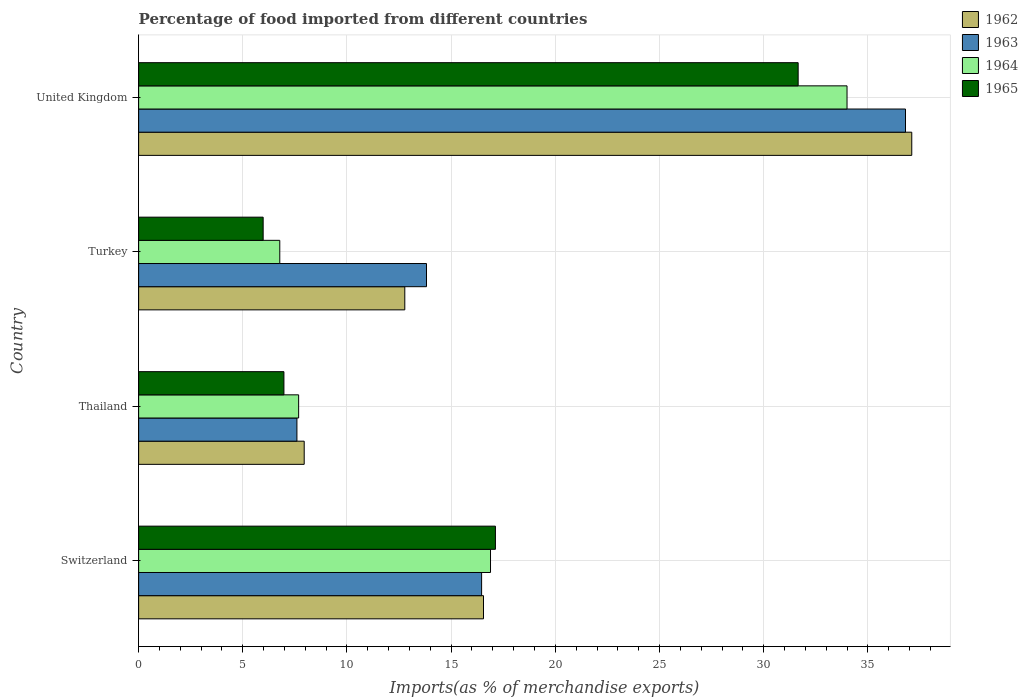How many different coloured bars are there?
Your answer should be compact. 4. How many groups of bars are there?
Offer a terse response. 4. Are the number of bars per tick equal to the number of legend labels?
Keep it short and to the point. Yes. Are the number of bars on each tick of the Y-axis equal?
Provide a short and direct response. Yes. What is the label of the 3rd group of bars from the top?
Ensure brevity in your answer.  Thailand. In how many cases, is the number of bars for a given country not equal to the number of legend labels?
Provide a short and direct response. 0. What is the percentage of imports to different countries in 1963 in Switzerland?
Your answer should be compact. 16.46. Across all countries, what is the maximum percentage of imports to different countries in 1962?
Keep it short and to the point. 37.11. Across all countries, what is the minimum percentage of imports to different countries in 1964?
Offer a terse response. 6.77. In which country was the percentage of imports to different countries in 1963 maximum?
Provide a short and direct response. United Kingdom. In which country was the percentage of imports to different countries in 1964 minimum?
Offer a very short reply. Turkey. What is the total percentage of imports to different countries in 1963 in the graph?
Offer a terse response. 74.68. What is the difference between the percentage of imports to different countries in 1963 in Thailand and that in Turkey?
Ensure brevity in your answer.  -6.22. What is the difference between the percentage of imports to different countries in 1965 in Turkey and the percentage of imports to different countries in 1962 in Thailand?
Your answer should be very brief. -1.97. What is the average percentage of imports to different countries in 1965 per country?
Your answer should be compact. 15.43. What is the difference between the percentage of imports to different countries in 1962 and percentage of imports to different countries in 1965 in Thailand?
Ensure brevity in your answer.  0.97. What is the ratio of the percentage of imports to different countries in 1964 in Switzerland to that in Turkey?
Your answer should be compact. 2.49. Is the percentage of imports to different countries in 1965 in Switzerland less than that in Thailand?
Your response must be concise. No. What is the difference between the highest and the second highest percentage of imports to different countries in 1962?
Your response must be concise. 20.56. What is the difference between the highest and the lowest percentage of imports to different countries in 1962?
Your answer should be very brief. 29.16. Is it the case that in every country, the sum of the percentage of imports to different countries in 1965 and percentage of imports to different countries in 1964 is greater than the sum of percentage of imports to different countries in 1962 and percentage of imports to different countries in 1963?
Your answer should be compact. No. What does the 4th bar from the bottom in United Kingdom represents?
Provide a short and direct response. 1965. Is it the case that in every country, the sum of the percentage of imports to different countries in 1963 and percentage of imports to different countries in 1965 is greater than the percentage of imports to different countries in 1964?
Give a very brief answer. Yes. Are all the bars in the graph horizontal?
Keep it short and to the point. Yes. What is the difference between two consecutive major ticks on the X-axis?
Offer a terse response. 5. Where does the legend appear in the graph?
Offer a very short reply. Top right. How many legend labels are there?
Offer a very short reply. 4. How are the legend labels stacked?
Your answer should be very brief. Vertical. What is the title of the graph?
Ensure brevity in your answer.  Percentage of food imported from different countries. Does "1976" appear as one of the legend labels in the graph?
Ensure brevity in your answer.  No. What is the label or title of the X-axis?
Your answer should be compact. Imports(as % of merchandise exports). What is the label or title of the Y-axis?
Your response must be concise. Country. What is the Imports(as % of merchandise exports) in 1962 in Switzerland?
Provide a succinct answer. 16.55. What is the Imports(as % of merchandise exports) in 1963 in Switzerland?
Offer a very short reply. 16.46. What is the Imports(as % of merchandise exports) in 1964 in Switzerland?
Offer a very short reply. 16.89. What is the Imports(as % of merchandise exports) in 1965 in Switzerland?
Give a very brief answer. 17.12. What is the Imports(as % of merchandise exports) of 1962 in Thailand?
Keep it short and to the point. 7.95. What is the Imports(as % of merchandise exports) of 1963 in Thailand?
Offer a terse response. 7.6. What is the Imports(as % of merchandise exports) of 1964 in Thailand?
Your answer should be compact. 7.68. What is the Imports(as % of merchandise exports) in 1965 in Thailand?
Your response must be concise. 6.97. What is the Imports(as % of merchandise exports) in 1962 in Turkey?
Provide a succinct answer. 12.77. What is the Imports(as % of merchandise exports) of 1963 in Turkey?
Ensure brevity in your answer.  13.82. What is the Imports(as % of merchandise exports) in 1964 in Turkey?
Offer a terse response. 6.77. What is the Imports(as % of merchandise exports) in 1965 in Turkey?
Give a very brief answer. 5.98. What is the Imports(as % of merchandise exports) in 1962 in United Kingdom?
Offer a very short reply. 37.11. What is the Imports(as % of merchandise exports) of 1963 in United Kingdom?
Your answer should be compact. 36.81. What is the Imports(as % of merchandise exports) of 1964 in United Kingdom?
Your answer should be very brief. 34. What is the Imports(as % of merchandise exports) of 1965 in United Kingdom?
Keep it short and to the point. 31.65. Across all countries, what is the maximum Imports(as % of merchandise exports) of 1962?
Ensure brevity in your answer.  37.11. Across all countries, what is the maximum Imports(as % of merchandise exports) in 1963?
Offer a very short reply. 36.81. Across all countries, what is the maximum Imports(as % of merchandise exports) of 1964?
Give a very brief answer. 34. Across all countries, what is the maximum Imports(as % of merchandise exports) of 1965?
Make the answer very short. 31.65. Across all countries, what is the minimum Imports(as % of merchandise exports) of 1962?
Keep it short and to the point. 7.95. Across all countries, what is the minimum Imports(as % of merchandise exports) of 1963?
Provide a succinct answer. 7.6. Across all countries, what is the minimum Imports(as % of merchandise exports) in 1964?
Ensure brevity in your answer.  6.77. Across all countries, what is the minimum Imports(as % of merchandise exports) in 1965?
Your answer should be compact. 5.98. What is the total Imports(as % of merchandise exports) of 1962 in the graph?
Keep it short and to the point. 74.38. What is the total Imports(as % of merchandise exports) of 1963 in the graph?
Your answer should be very brief. 74.68. What is the total Imports(as % of merchandise exports) in 1964 in the graph?
Your answer should be very brief. 65.34. What is the total Imports(as % of merchandise exports) in 1965 in the graph?
Your answer should be very brief. 61.73. What is the difference between the Imports(as % of merchandise exports) in 1962 in Switzerland and that in Thailand?
Provide a short and direct response. 8.61. What is the difference between the Imports(as % of merchandise exports) of 1963 in Switzerland and that in Thailand?
Your answer should be very brief. 8.86. What is the difference between the Imports(as % of merchandise exports) of 1964 in Switzerland and that in Thailand?
Make the answer very short. 9.21. What is the difference between the Imports(as % of merchandise exports) of 1965 in Switzerland and that in Thailand?
Offer a very short reply. 10.15. What is the difference between the Imports(as % of merchandise exports) in 1962 in Switzerland and that in Turkey?
Ensure brevity in your answer.  3.78. What is the difference between the Imports(as % of merchandise exports) of 1963 in Switzerland and that in Turkey?
Offer a terse response. 2.64. What is the difference between the Imports(as % of merchandise exports) in 1964 in Switzerland and that in Turkey?
Keep it short and to the point. 10.11. What is the difference between the Imports(as % of merchandise exports) in 1965 in Switzerland and that in Turkey?
Your answer should be compact. 11.15. What is the difference between the Imports(as % of merchandise exports) in 1962 in Switzerland and that in United Kingdom?
Ensure brevity in your answer.  -20.56. What is the difference between the Imports(as % of merchandise exports) of 1963 in Switzerland and that in United Kingdom?
Your answer should be compact. -20.35. What is the difference between the Imports(as % of merchandise exports) in 1964 in Switzerland and that in United Kingdom?
Your answer should be compact. -17.11. What is the difference between the Imports(as % of merchandise exports) of 1965 in Switzerland and that in United Kingdom?
Ensure brevity in your answer.  -14.53. What is the difference between the Imports(as % of merchandise exports) in 1962 in Thailand and that in Turkey?
Provide a succinct answer. -4.83. What is the difference between the Imports(as % of merchandise exports) in 1963 in Thailand and that in Turkey?
Provide a short and direct response. -6.22. What is the difference between the Imports(as % of merchandise exports) in 1964 in Thailand and that in Turkey?
Ensure brevity in your answer.  0.91. What is the difference between the Imports(as % of merchandise exports) of 1965 in Thailand and that in Turkey?
Your response must be concise. 1. What is the difference between the Imports(as % of merchandise exports) of 1962 in Thailand and that in United Kingdom?
Keep it short and to the point. -29.16. What is the difference between the Imports(as % of merchandise exports) in 1963 in Thailand and that in United Kingdom?
Provide a short and direct response. -29.21. What is the difference between the Imports(as % of merchandise exports) in 1964 in Thailand and that in United Kingdom?
Ensure brevity in your answer.  -26.32. What is the difference between the Imports(as % of merchandise exports) in 1965 in Thailand and that in United Kingdom?
Give a very brief answer. -24.68. What is the difference between the Imports(as % of merchandise exports) of 1962 in Turkey and that in United Kingdom?
Offer a terse response. -24.33. What is the difference between the Imports(as % of merchandise exports) of 1963 in Turkey and that in United Kingdom?
Make the answer very short. -22.99. What is the difference between the Imports(as % of merchandise exports) in 1964 in Turkey and that in United Kingdom?
Your answer should be very brief. -27.23. What is the difference between the Imports(as % of merchandise exports) of 1965 in Turkey and that in United Kingdom?
Your answer should be very brief. -25.68. What is the difference between the Imports(as % of merchandise exports) of 1962 in Switzerland and the Imports(as % of merchandise exports) of 1963 in Thailand?
Offer a very short reply. 8.96. What is the difference between the Imports(as % of merchandise exports) in 1962 in Switzerland and the Imports(as % of merchandise exports) in 1964 in Thailand?
Your answer should be very brief. 8.87. What is the difference between the Imports(as % of merchandise exports) of 1962 in Switzerland and the Imports(as % of merchandise exports) of 1965 in Thailand?
Ensure brevity in your answer.  9.58. What is the difference between the Imports(as % of merchandise exports) of 1963 in Switzerland and the Imports(as % of merchandise exports) of 1964 in Thailand?
Offer a terse response. 8.78. What is the difference between the Imports(as % of merchandise exports) of 1963 in Switzerland and the Imports(as % of merchandise exports) of 1965 in Thailand?
Your answer should be compact. 9.49. What is the difference between the Imports(as % of merchandise exports) in 1964 in Switzerland and the Imports(as % of merchandise exports) in 1965 in Thailand?
Your answer should be compact. 9.92. What is the difference between the Imports(as % of merchandise exports) in 1962 in Switzerland and the Imports(as % of merchandise exports) in 1963 in Turkey?
Keep it short and to the point. 2.74. What is the difference between the Imports(as % of merchandise exports) in 1962 in Switzerland and the Imports(as % of merchandise exports) in 1964 in Turkey?
Your response must be concise. 9.78. What is the difference between the Imports(as % of merchandise exports) in 1962 in Switzerland and the Imports(as % of merchandise exports) in 1965 in Turkey?
Your answer should be very brief. 10.58. What is the difference between the Imports(as % of merchandise exports) in 1963 in Switzerland and the Imports(as % of merchandise exports) in 1964 in Turkey?
Your response must be concise. 9.69. What is the difference between the Imports(as % of merchandise exports) of 1963 in Switzerland and the Imports(as % of merchandise exports) of 1965 in Turkey?
Ensure brevity in your answer.  10.48. What is the difference between the Imports(as % of merchandise exports) in 1964 in Switzerland and the Imports(as % of merchandise exports) in 1965 in Turkey?
Provide a short and direct response. 10.91. What is the difference between the Imports(as % of merchandise exports) in 1962 in Switzerland and the Imports(as % of merchandise exports) in 1963 in United Kingdom?
Offer a terse response. -20.25. What is the difference between the Imports(as % of merchandise exports) of 1962 in Switzerland and the Imports(as % of merchandise exports) of 1964 in United Kingdom?
Your answer should be compact. -17.45. What is the difference between the Imports(as % of merchandise exports) in 1962 in Switzerland and the Imports(as % of merchandise exports) in 1965 in United Kingdom?
Give a very brief answer. -15.1. What is the difference between the Imports(as % of merchandise exports) in 1963 in Switzerland and the Imports(as % of merchandise exports) in 1964 in United Kingdom?
Keep it short and to the point. -17.54. What is the difference between the Imports(as % of merchandise exports) in 1963 in Switzerland and the Imports(as % of merchandise exports) in 1965 in United Kingdom?
Give a very brief answer. -15.19. What is the difference between the Imports(as % of merchandise exports) of 1964 in Switzerland and the Imports(as % of merchandise exports) of 1965 in United Kingdom?
Your response must be concise. -14.77. What is the difference between the Imports(as % of merchandise exports) in 1962 in Thailand and the Imports(as % of merchandise exports) in 1963 in Turkey?
Keep it short and to the point. -5.87. What is the difference between the Imports(as % of merchandise exports) of 1962 in Thailand and the Imports(as % of merchandise exports) of 1964 in Turkey?
Provide a succinct answer. 1.17. What is the difference between the Imports(as % of merchandise exports) in 1962 in Thailand and the Imports(as % of merchandise exports) in 1965 in Turkey?
Ensure brevity in your answer.  1.97. What is the difference between the Imports(as % of merchandise exports) in 1963 in Thailand and the Imports(as % of merchandise exports) in 1964 in Turkey?
Offer a very short reply. 0.82. What is the difference between the Imports(as % of merchandise exports) of 1963 in Thailand and the Imports(as % of merchandise exports) of 1965 in Turkey?
Offer a very short reply. 1.62. What is the difference between the Imports(as % of merchandise exports) of 1964 in Thailand and the Imports(as % of merchandise exports) of 1965 in Turkey?
Offer a very short reply. 1.7. What is the difference between the Imports(as % of merchandise exports) of 1962 in Thailand and the Imports(as % of merchandise exports) of 1963 in United Kingdom?
Give a very brief answer. -28.86. What is the difference between the Imports(as % of merchandise exports) of 1962 in Thailand and the Imports(as % of merchandise exports) of 1964 in United Kingdom?
Ensure brevity in your answer.  -26.05. What is the difference between the Imports(as % of merchandise exports) of 1962 in Thailand and the Imports(as % of merchandise exports) of 1965 in United Kingdom?
Offer a very short reply. -23.71. What is the difference between the Imports(as % of merchandise exports) of 1963 in Thailand and the Imports(as % of merchandise exports) of 1964 in United Kingdom?
Offer a terse response. -26.4. What is the difference between the Imports(as % of merchandise exports) of 1963 in Thailand and the Imports(as % of merchandise exports) of 1965 in United Kingdom?
Make the answer very short. -24.06. What is the difference between the Imports(as % of merchandise exports) of 1964 in Thailand and the Imports(as % of merchandise exports) of 1965 in United Kingdom?
Your answer should be very brief. -23.97. What is the difference between the Imports(as % of merchandise exports) in 1962 in Turkey and the Imports(as % of merchandise exports) in 1963 in United Kingdom?
Provide a short and direct response. -24.03. What is the difference between the Imports(as % of merchandise exports) in 1962 in Turkey and the Imports(as % of merchandise exports) in 1964 in United Kingdom?
Your response must be concise. -21.23. What is the difference between the Imports(as % of merchandise exports) of 1962 in Turkey and the Imports(as % of merchandise exports) of 1965 in United Kingdom?
Make the answer very short. -18.88. What is the difference between the Imports(as % of merchandise exports) of 1963 in Turkey and the Imports(as % of merchandise exports) of 1964 in United Kingdom?
Your answer should be very brief. -20.18. What is the difference between the Imports(as % of merchandise exports) in 1963 in Turkey and the Imports(as % of merchandise exports) in 1965 in United Kingdom?
Make the answer very short. -17.84. What is the difference between the Imports(as % of merchandise exports) in 1964 in Turkey and the Imports(as % of merchandise exports) in 1965 in United Kingdom?
Provide a short and direct response. -24.88. What is the average Imports(as % of merchandise exports) in 1962 per country?
Your answer should be compact. 18.6. What is the average Imports(as % of merchandise exports) of 1963 per country?
Ensure brevity in your answer.  18.67. What is the average Imports(as % of merchandise exports) in 1964 per country?
Offer a terse response. 16.34. What is the average Imports(as % of merchandise exports) of 1965 per country?
Your answer should be compact. 15.43. What is the difference between the Imports(as % of merchandise exports) in 1962 and Imports(as % of merchandise exports) in 1963 in Switzerland?
Provide a succinct answer. 0.09. What is the difference between the Imports(as % of merchandise exports) of 1962 and Imports(as % of merchandise exports) of 1964 in Switzerland?
Provide a short and direct response. -0.34. What is the difference between the Imports(as % of merchandise exports) of 1962 and Imports(as % of merchandise exports) of 1965 in Switzerland?
Offer a terse response. -0.57. What is the difference between the Imports(as % of merchandise exports) in 1963 and Imports(as % of merchandise exports) in 1964 in Switzerland?
Your response must be concise. -0.43. What is the difference between the Imports(as % of merchandise exports) in 1963 and Imports(as % of merchandise exports) in 1965 in Switzerland?
Your answer should be very brief. -0.66. What is the difference between the Imports(as % of merchandise exports) in 1964 and Imports(as % of merchandise exports) in 1965 in Switzerland?
Provide a succinct answer. -0.24. What is the difference between the Imports(as % of merchandise exports) in 1962 and Imports(as % of merchandise exports) in 1963 in Thailand?
Give a very brief answer. 0.35. What is the difference between the Imports(as % of merchandise exports) of 1962 and Imports(as % of merchandise exports) of 1964 in Thailand?
Ensure brevity in your answer.  0.27. What is the difference between the Imports(as % of merchandise exports) in 1962 and Imports(as % of merchandise exports) in 1965 in Thailand?
Provide a short and direct response. 0.97. What is the difference between the Imports(as % of merchandise exports) of 1963 and Imports(as % of merchandise exports) of 1964 in Thailand?
Offer a very short reply. -0.08. What is the difference between the Imports(as % of merchandise exports) in 1963 and Imports(as % of merchandise exports) in 1965 in Thailand?
Keep it short and to the point. 0.62. What is the difference between the Imports(as % of merchandise exports) of 1964 and Imports(as % of merchandise exports) of 1965 in Thailand?
Offer a very short reply. 0.71. What is the difference between the Imports(as % of merchandise exports) of 1962 and Imports(as % of merchandise exports) of 1963 in Turkey?
Provide a short and direct response. -1.04. What is the difference between the Imports(as % of merchandise exports) of 1962 and Imports(as % of merchandise exports) of 1964 in Turkey?
Keep it short and to the point. 6. What is the difference between the Imports(as % of merchandise exports) in 1962 and Imports(as % of merchandise exports) in 1965 in Turkey?
Your answer should be very brief. 6.8. What is the difference between the Imports(as % of merchandise exports) in 1963 and Imports(as % of merchandise exports) in 1964 in Turkey?
Provide a short and direct response. 7.04. What is the difference between the Imports(as % of merchandise exports) in 1963 and Imports(as % of merchandise exports) in 1965 in Turkey?
Provide a short and direct response. 7.84. What is the difference between the Imports(as % of merchandise exports) of 1964 and Imports(as % of merchandise exports) of 1965 in Turkey?
Your answer should be compact. 0.8. What is the difference between the Imports(as % of merchandise exports) of 1962 and Imports(as % of merchandise exports) of 1963 in United Kingdom?
Your response must be concise. 0.3. What is the difference between the Imports(as % of merchandise exports) in 1962 and Imports(as % of merchandise exports) in 1964 in United Kingdom?
Provide a succinct answer. 3.11. What is the difference between the Imports(as % of merchandise exports) in 1962 and Imports(as % of merchandise exports) in 1965 in United Kingdom?
Offer a terse response. 5.45. What is the difference between the Imports(as % of merchandise exports) in 1963 and Imports(as % of merchandise exports) in 1964 in United Kingdom?
Your answer should be compact. 2.81. What is the difference between the Imports(as % of merchandise exports) of 1963 and Imports(as % of merchandise exports) of 1965 in United Kingdom?
Keep it short and to the point. 5.15. What is the difference between the Imports(as % of merchandise exports) of 1964 and Imports(as % of merchandise exports) of 1965 in United Kingdom?
Give a very brief answer. 2.35. What is the ratio of the Imports(as % of merchandise exports) of 1962 in Switzerland to that in Thailand?
Your answer should be compact. 2.08. What is the ratio of the Imports(as % of merchandise exports) in 1963 in Switzerland to that in Thailand?
Keep it short and to the point. 2.17. What is the ratio of the Imports(as % of merchandise exports) of 1964 in Switzerland to that in Thailand?
Give a very brief answer. 2.2. What is the ratio of the Imports(as % of merchandise exports) of 1965 in Switzerland to that in Thailand?
Offer a terse response. 2.46. What is the ratio of the Imports(as % of merchandise exports) in 1962 in Switzerland to that in Turkey?
Offer a very short reply. 1.3. What is the ratio of the Imports(as % of merchandise exports) in 1963 in Switzerland to that in Turkey?
Provide a succinct answer. 1.19. What is the ratio of the Imports(as % of merchandise exports) in 1964 in Switzerland to that in Turkey?
Provide a succinct answer. 2.49. What is the ratio of the Imports(as % of merchandise exports) in 1965 in Switzerland to that in Turkey?
Ensure brevity in your answer.  2.87. What is the ratio of the Imports(as % of merchandise exports) in 1962 in Switzerland to that in United Kingdom?
Your response must be concise. 0.45. What is the ratio of the Imports(as % of merchandise exports) in 1963 in Switzerland to that in United Kingdom?
Keep it short and to the point. 0.45. What is the ratio of the Imports(as % of merchandise exports) of 1964 in Switzerland to that in United Kingdom?
Give a very brief answer. 0.5. What is the ratio of the Imports(as % of merchandise exports) in 1965 in Switzerland to that in United Kingdom?
Offer a very short reply. 0.54. What is the ratio of the Imports(as % of merchandise exports) of 1962 in Thailand to that in Turkey?
Your answer should be very brief. 0.62. What is the ratio of the Imports(as % of merchandise exports) of 1963 in Thailand to that in Turkey?
Keep it short and to the point. 0.55. What is the ratio of the Imports(as % of merchandise exports) in 1964 in Thailand to that in Turkey?
Offer a terse response. 1.13. What is the ratio of the Imports(as % of merchandise exports) in 1965 in Thailand to that in Turkey?
Your answer should be compact. 1.17. What is the ratio of the Imports(as % of merchandise exports) of 1962 in Thailand to that in United Kingdom?
Offer a very short reply. 0.21. What is the ratio of the Imports(as % of merchandise exports) of 1963 in Thailand to that in United Kingdom?
Your response must be concise. 0.21. What is the ratio of the Imports(as % of merchandise exports) of 1964 in Thailand to that in United Kingdom?
Your answer should be very brief. 0.23. What is the ratio of the Imports(as % of merchandise exports) in 1965 in Thailand to that in United Kingdom?
Ensure brevity in your answer.  0.22. What is the ratio of the Imports(as % of merchandise exports) in 1962 in Turkey to that in United Kingdom?
Keep it short and to the point. 0.34. What is the ratio of the Imports(as % of merchandise exports) of 1963 in Turkey to that in United Kingdom?
Make the answer very short. 0.38. What is the ratio of the Imports(as % of merchandise exports) in 1964 in Turkey to that in United Kingdom?
Make the answer very short. 0.2. What is the ratio of the Imports(as % of merchandise exports) of 1965 in Turkey to that in United Kingdom?
Provide a succinct answer. 0.19. What is the difference between the highest and the second highest Imports(as % of merchandise exports) in 1962?
Your answer should be very brief. 20.56. What is the difference between the highest and the second highest Imports(as % of merchandise exports) of 1963?
Your answer should be very brief. 20.35. What is the difference between the highest and the second highest Imports(as % of merchandise exports) in 1964?
Ensure brevity in your answer.  17.11. What is the difference between the highest and the second highest Imports(as % of merchandise exports) of 1965?
Offer a terse response. 14.53. What is the difference between the highest and the lowest Imports(as % of merchandise exports) in 1962?
Keep it short and to the point. 29.16. What is the difference between the highest and the lowest Imports(as % of merchandise exports) of 1963?
Provide a succinct answer. 29.21. What is the difference between the highest and the lowest Imports(as % of merchandise exports) in 1964?
Offer a very short reply. 27.23. What is the difference between the highest and the lowest Imports(as % of merchandise exports) in 1965?
Provide a short and direct response. 25.68. 